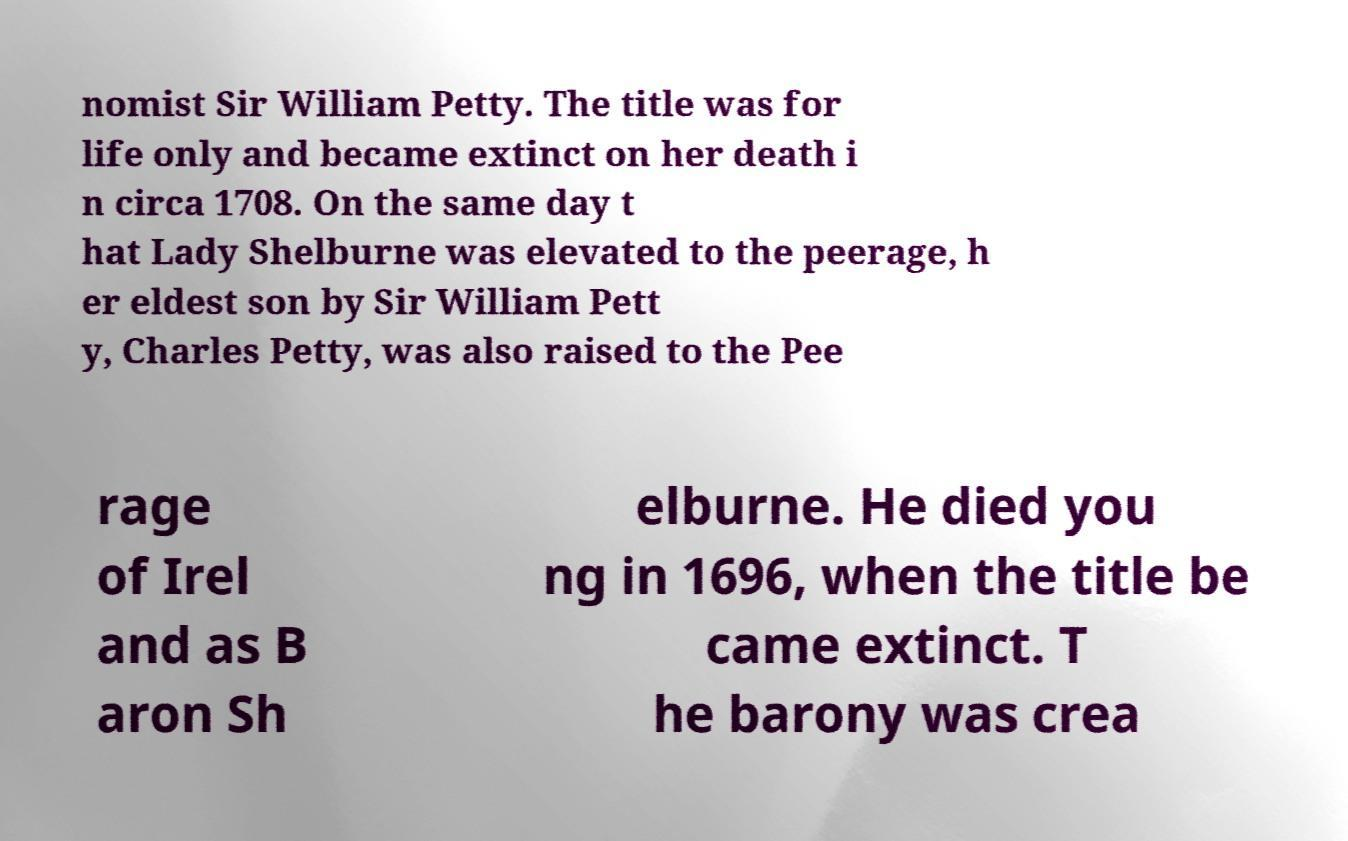I need the written content from this picture converted into text. Can you do that? nomist Sir William Petty. The title was for life only and became extinct on her death i n circa 1708. On the same day t hat Lady Shelburne was elevated to the peerage, h er eldest son by Sir William Pett y, Charles Petty, was also raised to the Pee rage of Irel and as B aron Sh elburne. He died you ng in 1696, when the title be came extinct. T he barony was crea 